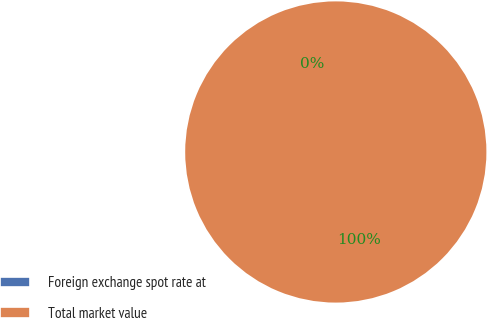Convert chart to OTSL. <chart><loc_0><loc_0><loc_500><loc_500><pie_chart><fcel>Foreign exchange spot rate at<fcel>Total market value<nl><fcel>0.0%<fcel>100.0%<nl></chart> 